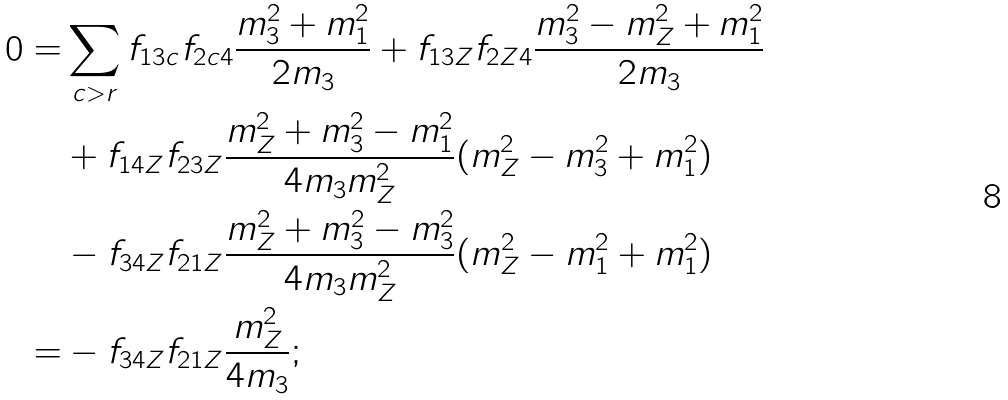Convert formula to latex. <formula><loc_0><loc_0><loc_500><loc_500>0 = & \sum _ { c > r } f _ { 1 3 c } f _ { 2 c 4 } \frac { m _ { 3 } ^ { 2 } + m _ { 1 } ^ { 2 } } { 2 m _ { 3 } } + f _ { 1 3 Z } f _ { 2 Z 4 } \frac { m _ { 3 } ^ { 2 } - m _ { Z } ^ { 2 } + m _ { 1 } ^ { 2 } } { 2 m _ { 3 } } \\ & + f _ { 1 4 Z } f _ { 2 3 Z } \frac { m _ { Z } ^ { 2 } + m _ { 3 } ^ { 2 } - m _ { 1 } ^ { 2 } } { 4 m _ { 3 } m _ { Z } ^ { 2 } } ( m _ { Z } ^ { 2 } - m _ { 3 } ^ { 2 } + m _ { 1 } ^ { 2 } ) \\ & - f _ { 3 4 Z } f _ { 2 1 Z } \frac { m _ { Z } ^ { 2 } + m _ { 3 } ^ { 2 } - m _ { 3 } ^ { 2 } } { 4 m _ { 3 } m _ { Z } ^ { 2 } } ( m _ { Z } ^ { 2 } - m _ { 1 } ^ { 2 } + m _ { 1 } ^ { 2 } ) \\ = & - f _ { 3 4 Z } f _ { 2 1 Z } \frac { m _ { Z } ^ { 2 } } { 4 m _ { 3 } } ;</formula> 